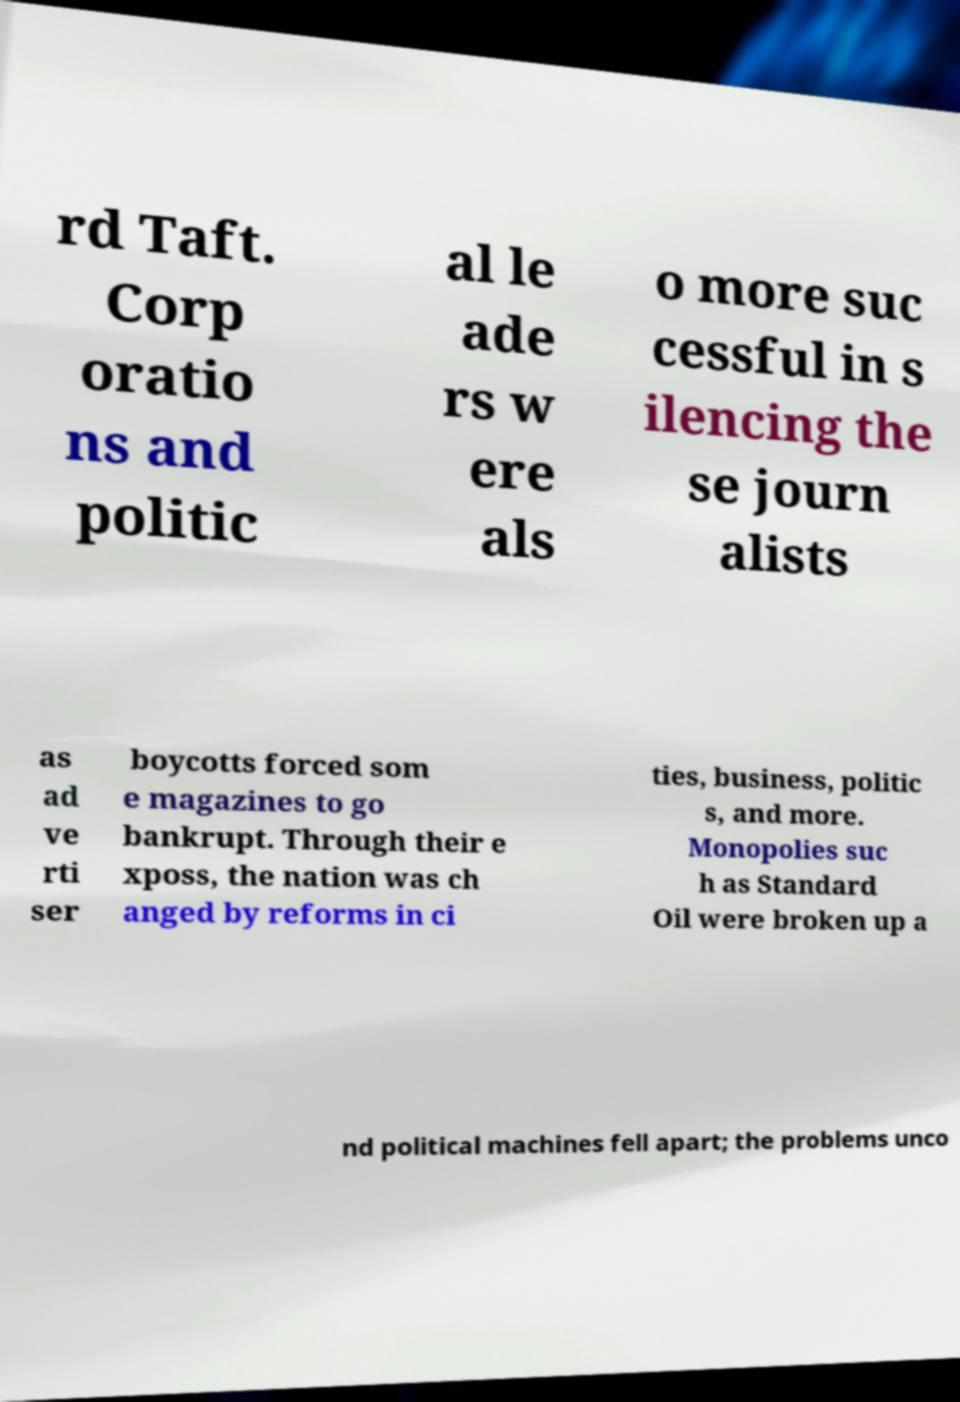Please identify and transcribe the text found in this image. rd Taft. Corp oratio ns and politic al le ade rs w ere als o more suc cessful in s ilencing the se journ alists as ad ve rti ser boycotts forced som e magazines to go bankrupt. Through their e xposs, the nation was ch anged by reforms in ci ties, business, politic s, and more. Monopolies suc h as Standard Oil were broken up a nd political machines fell apart; the problems unco 